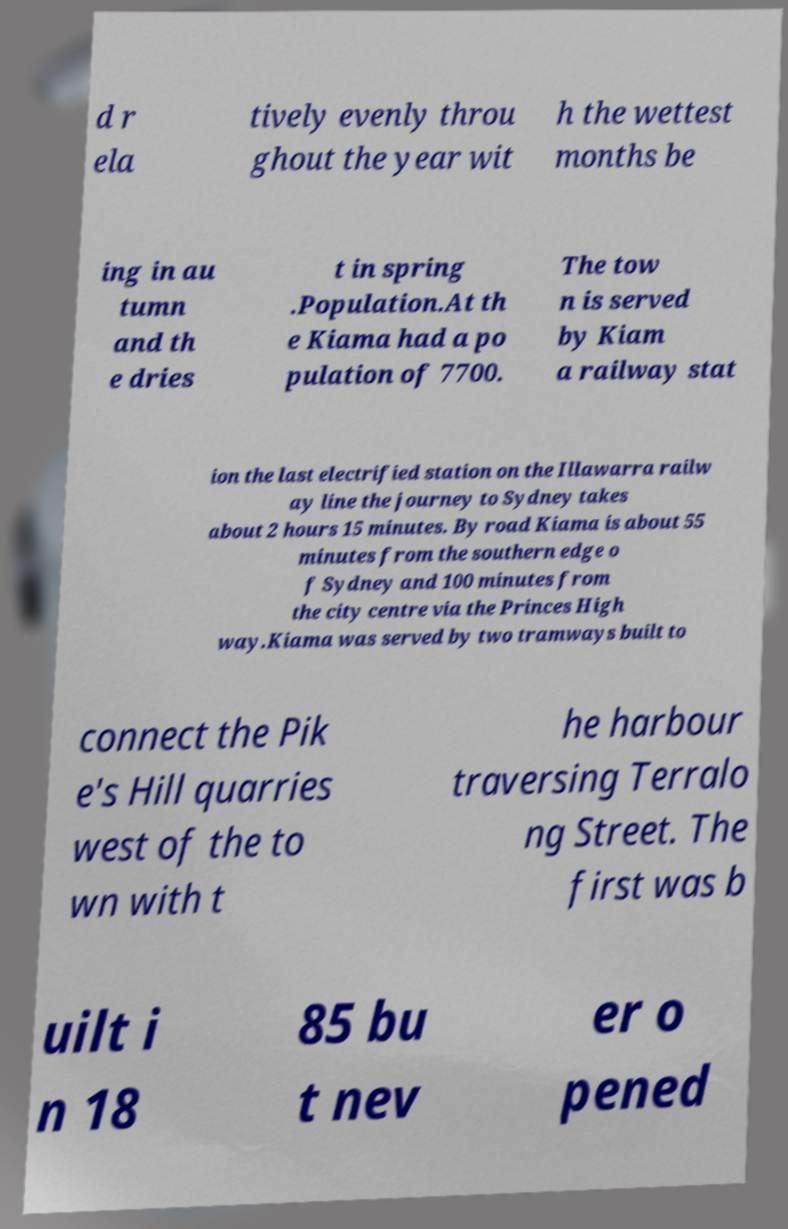Please read and relay the text visible in this image. What does it say? d r ela tively evenly throu ghout the year wit h the wettest months be ing in au tumn and th e dries t in spring .Population.At th e Kiama had a po pulation of 7700. The tow n is served by Kiam a railway stat ion the last electrified station on the Illawarra railw ay line the journey to Sydney takes about 2 hours 15 minutes. By road Kiama is about 55 minutes from the southern edge o f Sydney and 100 minutes from the city centre via the Princes High way.Kiama was served by two tramways built to connect the Pik e's Hill quarries west of the to wn with t he harbour traversing Terralo ng Street. The first was b uilt i n 18 85 bu t nev er o pened 